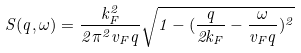Convert formula to latex. <formula><loc_0><loc_0><loc_500><loc_500>S ( q , \omega ) = \frac { k _ { F } ^ { 2 } } { 2 \pi ^ { 2 } v _ { F } q } \sqrt { 1 - ( \frac { q } { 2 k _ { F } } - \frac { \omega } { v _ { F } q } ) ^ { 2 } }</formula> 